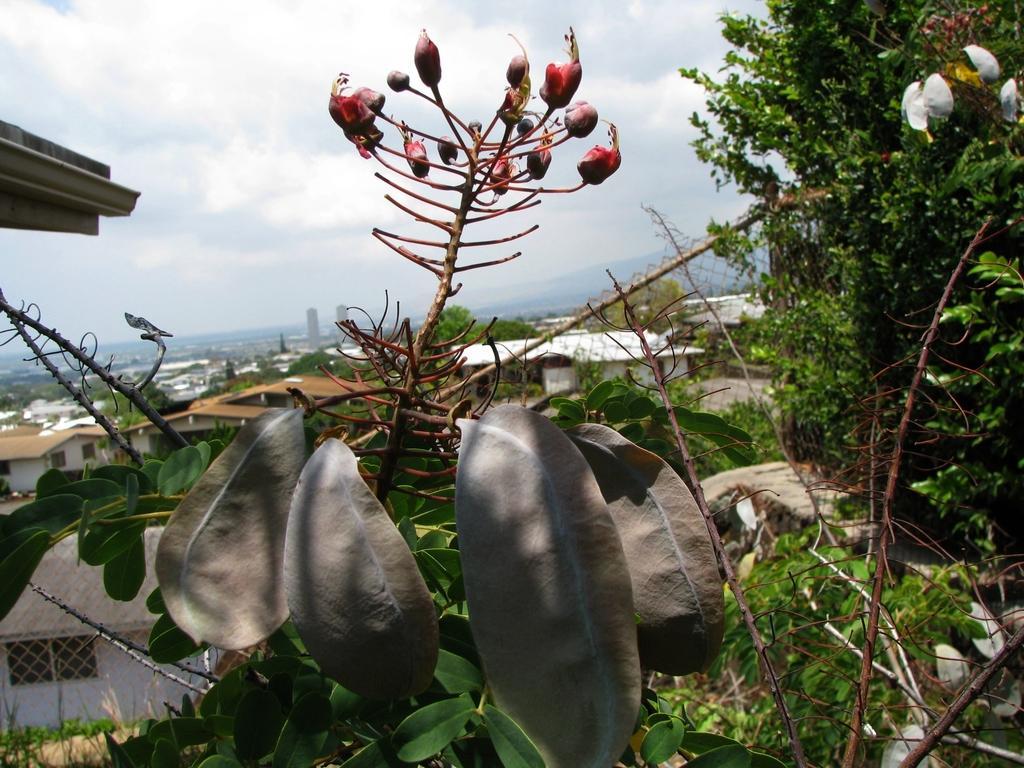Can you describe this image briefly? In this image there is a net fencing. There are plants with flowers. There are trees. There are buildings. There are clouds in the sky. 